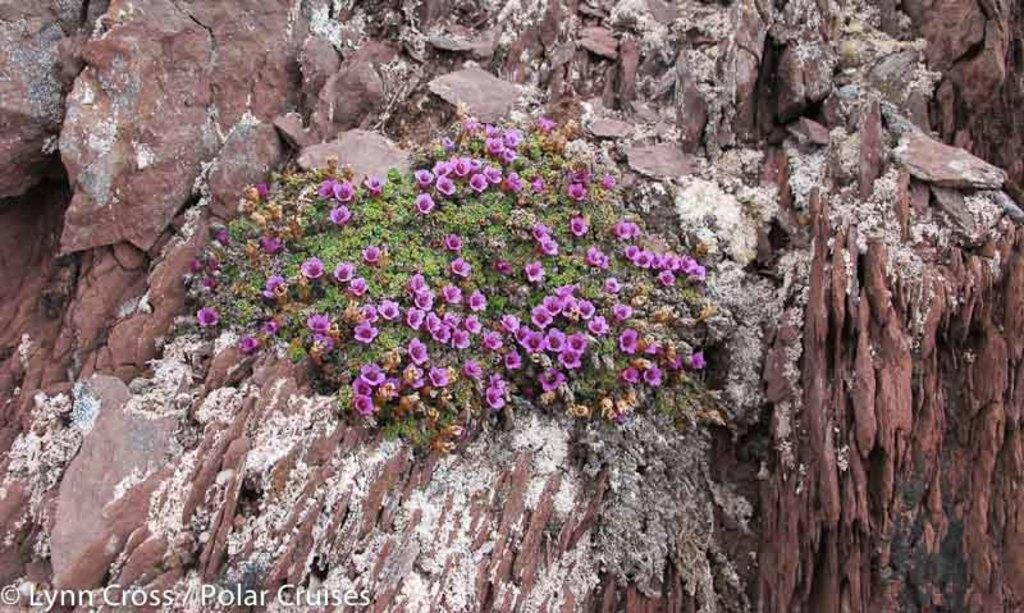What type of landscape feature is present in the image? There is a hill in the image. What type of plants can be seen in the image? There are flowers and leaves in the image. Where is the text located in the image? The text is at the left bottom of the image. What type of shirt is visible in the image? There is no shirt visible in the image; it features a hill, flowers, leaves, and text. 